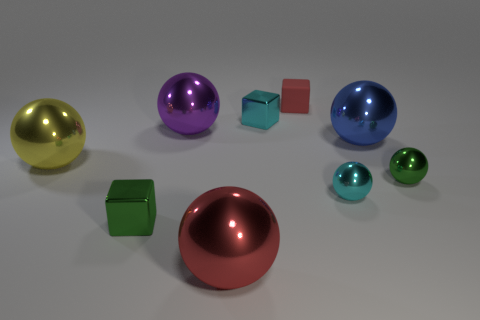Subtract all blue balls. How many balls are left? 5 Subtract all tiny balls. How many balls are left? 4 Subtract all purple balls. Subtract all blue blocks. How many balls are left? 5 Add 1 blue balls. How many objects exist? 10 Subtract all blocks. How many objects are left? 6 Add 6 big purple spheres. How many big purple spheres are left? 7 Add 2 small cyan metal cylinders. How many small cyan metal cylinders exist? 2 Subtract 0 brown cylinders. How many objects are left? 9 Subtract all large green shiny objects. Subtract all big red things. How many objects are left? 8 